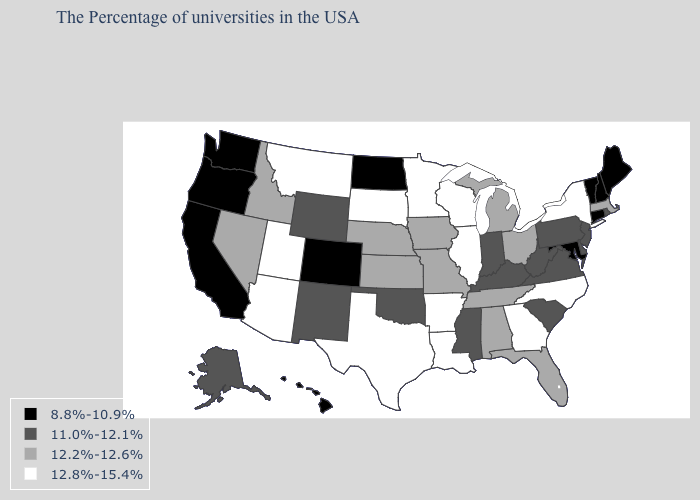Which states hav the highest value in the Northeast?
Concise answer only. New York. What is the highest value in the Northeast ?
Write a very short answer. 12.8%-15.4%. What is the value of Florida?
Answer briefly. 12.2%-12.6%. What is the value of Wisconsin?
Write a very short answer. 12.8%-15.4%. Does the first symbol in the legend represent the smallest category?
Concise answer only. Yes. What is the lowest value in the South?
Write a very short answer. 8.8%-10.9%. What is the value of Virginia?
Be succinct. 11.0%-12.1%. Does the map have missing data?
Be succinct. No. Name the states that have a value in the range 12.8%-15.4%?
Keep it brief. New York, North Carolina, Georgia, Wisconsin, Illinois, Louisiana, Arkansas, Minnesota, Texas, South Dakota, Utah, Montana, Arizona. Name the states that have a value in the range 12.8%-15.4%?
Quick response, please. New York, North Carolina, Georgia, Wisconsin, Illinois, Louisiana, Arkansas, Minnesota, Texas, South Dakota, Utah, Montana, Arizona. Does New Jersey have a higher value than Nebraska?
Short answer required. No. What is the highest value in states that border Kansas?
Give a very brief answer. 12.2%-12.6%. Does the map have missing data?
Give a very brief answer. No. Does North Dakota have a higher value than Arizona?
Quick response, please. No. Does the first symbol in the legend represent the smallest category?
Be succinct. Yes. 